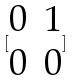<formula> <loc_0><loc_0><loc_500><loc_500>[ \begin{matrix} 0 & 1 \\ 0 & 0 \end{matrix} ]</formula> 